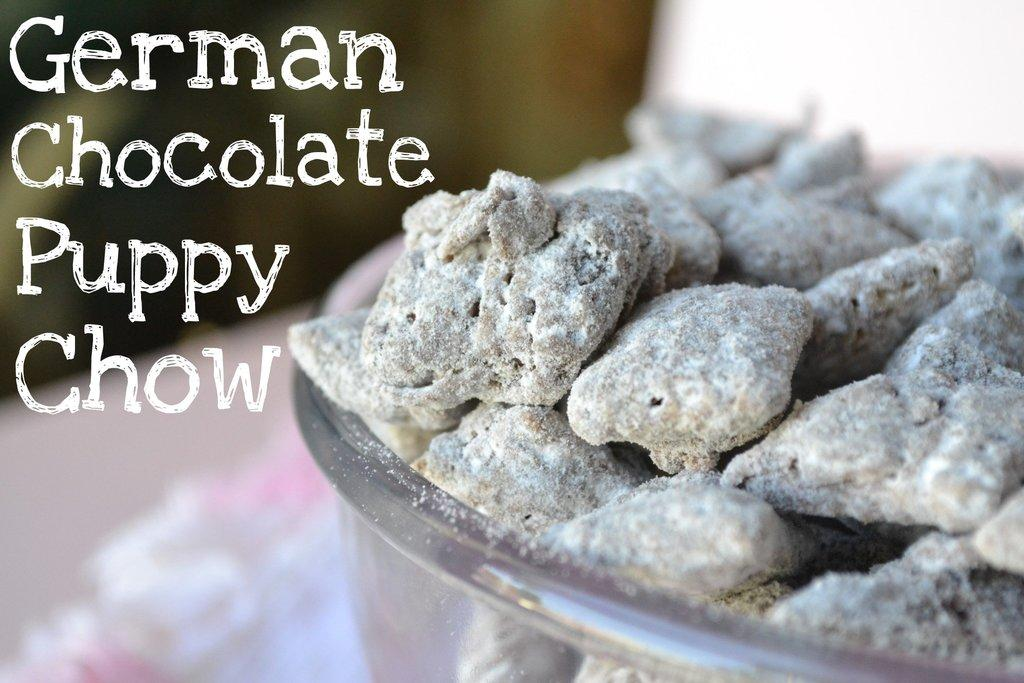What is in the bowl that is visible in the image? The bowl is full of German chocolate puppy chow. Can you describe the contents of the bowl in more detail? The bowl contains German chocolate puppy chow, which is a sweet treat typically made with chocolate, peanut butter, and other ingredients. How much tax is applied to the German chocolate puppy chow in the image? There is no mention of tax in the image, and it is not applicable to the contents of the bowl. 